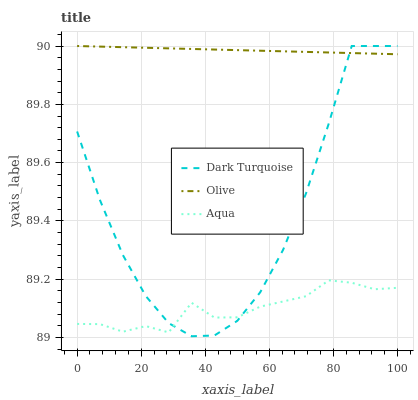Does Aqua have the minimum area under the curve?
Answer yes or no. Yes. Does Olive have the maximum area under the curve?
Answer yes or no. Yes. Does Dark Turquoise have the minimum area under the curve?
Answer yes or no. No. Does Dark Turquoise have the maximum area under the curve?
Answer yes or no. No. Is Olive the smoothest?
Answer yes or no. Yes. Is Dark Turquoise the roughest?
Answer yes or no. Yes. Is Aqua the smoothest?
Answer yes or no. No. Is Aqua the roughest?
Answer yes or no. No. Does Dark Turquoise have the lowest value?
Answer yes or no. Yes. Does Aqua have the lowest value?
Answer yes or no. No. Does Dark Turquoise have the highest value?
Answer yes or no. Yes. Does Aqua have the highest value?
Answer yes or no. No. Is Aqua less than Olive?
Answer yes or no. Yes. Is Olive greater than Aqua?
Answer yes or no. Yes. Does Dark Turquoise intersect Olive?
Answer yes or no. Yes. Is Dark Turquoise less than Olive?
Answer yes or no. No. Is Dark Turquoise greater than Olive?
Answer yes or no. No. Does Aqua intersect Olive?
Answer yes or no. No. 